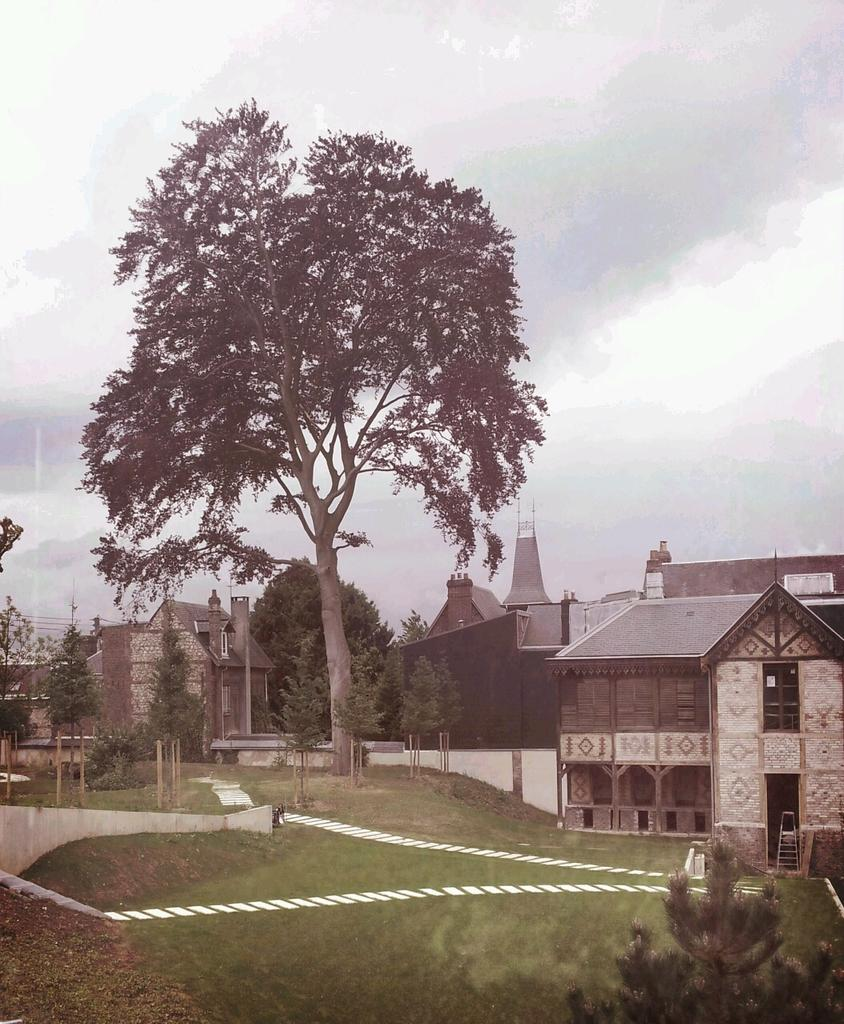What can be seen in the background of the image? In the background of the image, there is sky, trees, and houses visible. What type of structures are present in the image? There are poles in the image. What type of vegetation is visible in the image? There is grass visible in the image. Where is a plant located in the image? A plant can be found in the bottom right corner of the image. What is the rate at which the jar of bread is being consumed in the image? There is no jar or bread present in the image, so it is not possible to determine a consumption rate. 